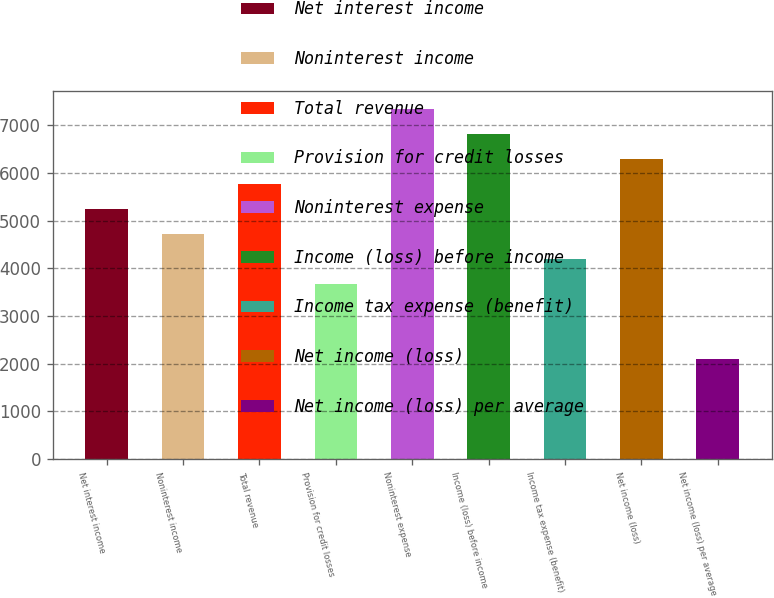Convert chart to OTSL. <chart><loc_0><loc_0><loc_500><loc_500><bar_chart><fcel>Net interest income<fcel>Noninterest income<fcel>Total revenue<fcel>Provision for credit losses<fcel>Noninterest expense<fcel>Income (loss) before income<fcel>Income tax expense (benefit)<fcel>Net income (loss)<fcel>Net income (loss) per average<nl><fcel>5251.99<fcel>4726.86<fcel>5777.12<fcel>3676.6<fcel>7352.51<fcel>6827.38<fcel>4201.73<fcel>6302.25<fcel>2101.21<nl></chart> 